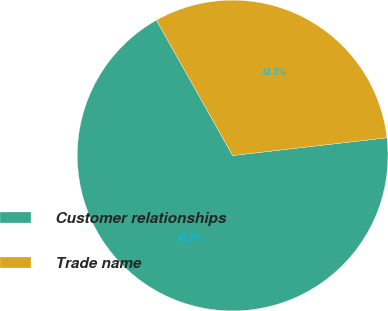Convert chart to OTSL. <chart><loc_0><loc_0><loc_500><loc_500><pie_chart><fcel>Customer relationships<fcel>Trade name<nl><fcel>68.66%<fcel>31.34%<nl></chart> 